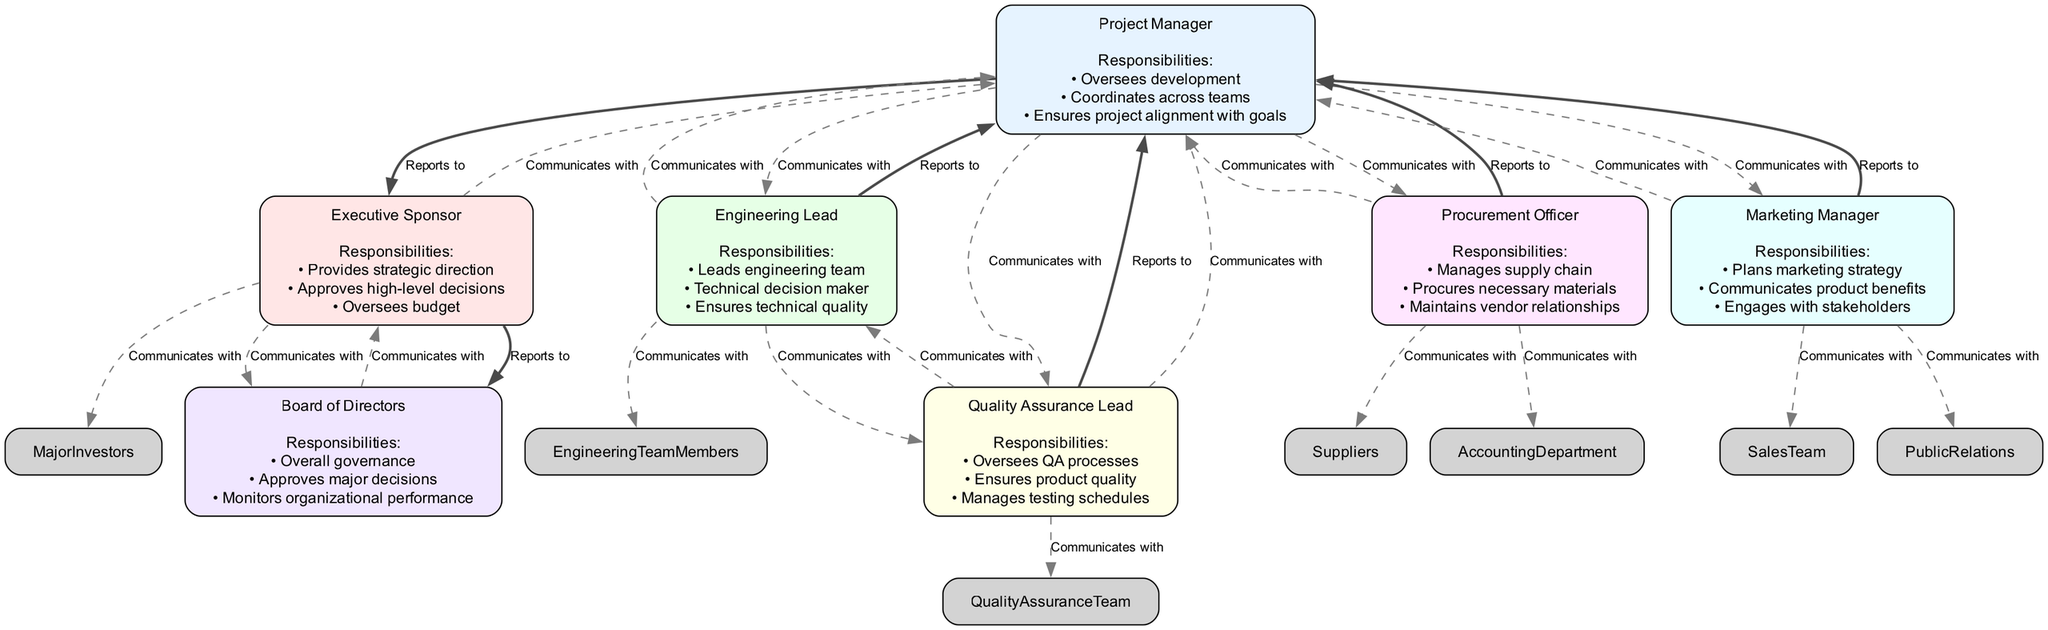What is the main responsibility of the Project Manager? The diagram indicates that the Project Manager's primary responsibilities include overseeing development, coordinating across teams, and ensuring project alignment with goals.
Answer: Oversees development Who does the Executive Sponsor report to? According to the diagram, the Executive Sponsor reports to the Board of Directors, as indicated by the edge labeled "Reports to."
Answer: Board of Directors How many stakeholders communicate with the Quality Assurance Lead? The diagram shows three stakeholders that communicate with the Quality Assurance Lead: Project Manager, Engineering Lead, and Quality Assurance Team. Thus, the count is three.
Answer: 3 Which node has the responsibility of approving high-level decisions? Based on the information in the diagram, the Executive Sponsor holds the responsibility of approving high-level decisions as illustrated in their responsibilities section.
Answer: Executive Sponsor How are the Engineering Lead and Quality Assurance Lead connected? The diagram indicates that the connection between the Engineering Lead and Quality Assurance Lead is established through a dashed edge labeled "Communicates with," which means they communicate regularly.
Answer: Communicates with What is the total number of nodes in this diagram? By counting the nodes representing individual roles, the diagram reveals there are six stakeholders: Project Manager, Executive Sponsor, Engineering Lead, Quality Assurance Lead, Procurement Officer, and Marketing Manager, thus the total is six.
Answer: 6 Which position maintains vendor relationships? The Procurement Officer is responsible for maintaining vendor relationships, which is specifically listed under their responsibilities in the diagram.
Answer: Procurement Officer How does the Marketing Manager communicate with the Project Manager? The diagram shows a dashed edge labeled "Communicates with," indicating that the Marketing Manager has a communication relationship with the Project Manager, meaning they interact regularly for project alignment.
Answer: Communicates with Name two stakeholders that report directly to the Project Manager. The diagram outlines that both the Engineering Lead and Quality Assurance Lead report to the Project Manager as indicated by respective solid edges labeled "Reports to."
Answer: Engineering Lead, Quality Assurance Lead What is the primary responsibility of the Board of Directors? The diagram states that one of the main responsibilities of the Board of Directors is overall governance, as shown in their responsibilities section.
Answer: Overall governance 